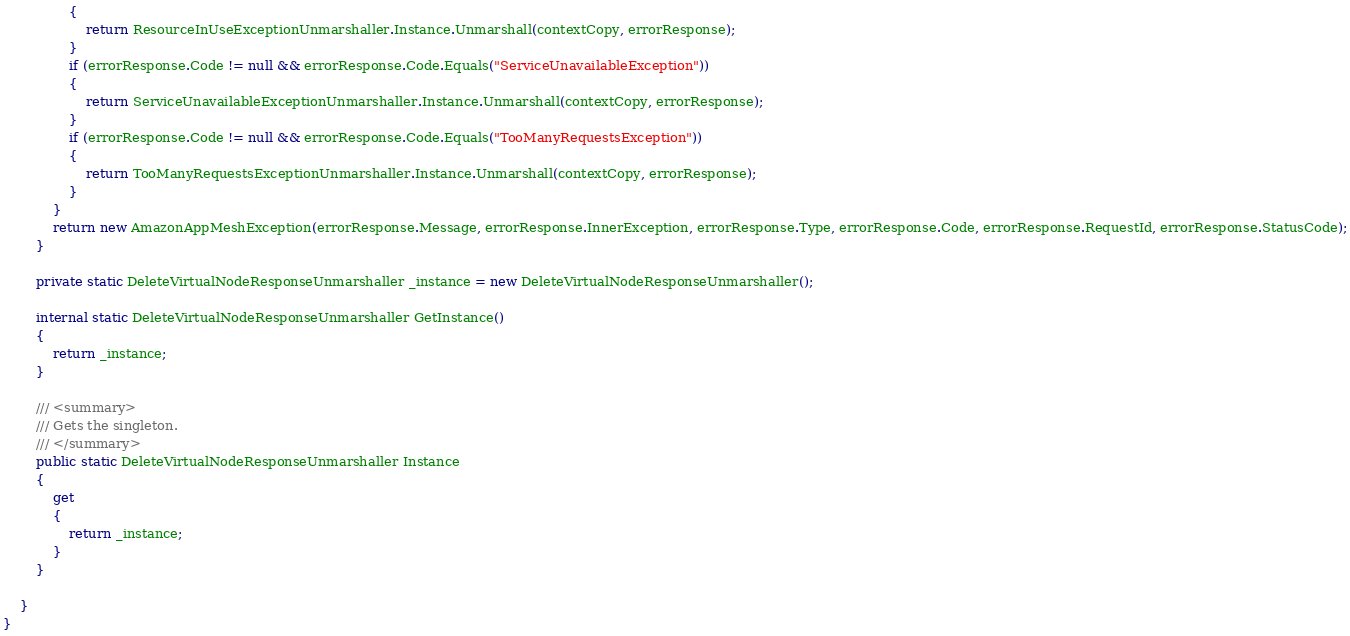Convert code to text. <code><loc_0><loc_0><loc_500><loc_500><_C#_>                {
                    return ResourceInUseExceptionUnmarshaller.Instance.Unmarshall(contextCopy, errorResponse);
                }
                if (errorResponse.Code != null && errorResponse.Code.Equals("ServiceUnavailableException"))
                {
                    return ServiceUnavailableExceptionUnmarshaller.Instance.Unmarshall(contextCopy, errorResponse);
                }
                if (errorResponse.Code != null && errorResponse.Code.Equals("TooManyRequestsException"))
                {
                    return TooManyRequestsExceptionUnmarshaller.Instance.Unmarshall(contextCopy, errorResponse);
                }
            }
            return new AmazonAppMeshException(errorResponse.Message, errorResponse.InnerException, errorResponse.Type, errorResponse.Code, errorResponse.RequestId, errorResponse.StatusCode);
        }

        private static DeleteVirtualNodeResponseUnmarshaller _instance = new DeleteVirtualNodeResponseUnmarshaller();        

        internal static DeleteVirtualNodeResponseUnmarshaller GetInstance()
        {
            return _instance;
        }

        /// <summary>
        /// Gets the singleton.
        /// </summary>  
        public static DeleteVirtualNodeResponseUnmarshaller Instance
        {
            get
            {
                return _instance;
            }
        }

    }
}</code> 